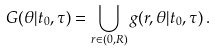<formula> <loc_0><loc_0><loc_500><loc_500>G ( \theta | t _ { 0 } , \tau ) = \bigcup _ { r \in ( 0 , R ) } g ( r , \theta | t _ { 0 } , \tau ) \, .</formula> 